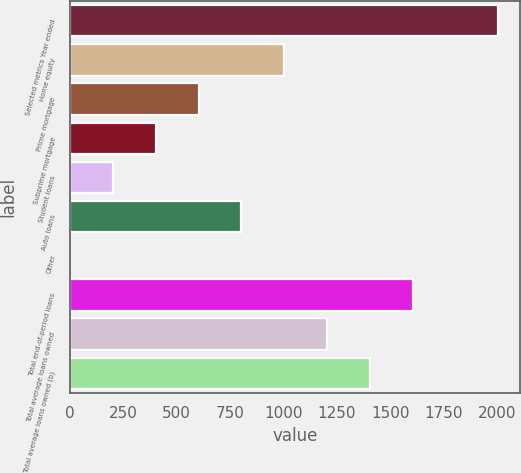Convert chart to OTSL. <chart><loc_0><loc_0><loc_500><loc_500><bar_chart><fcel>Selected metrics Year ended<fcel>Home equity<fcel>Prime mortgage<fcel>Subprime mortgage<fcel>Student loans<fcel>Auto loans<fcel>Other<fcel>Total end-of-period loans<fcel>Total average loans owned<fcel>Total average loans owned (b)<nl><fcel>2007<fcel>1004.55<fcel>603.57<fcel>403.08<fcel>202.59<fcel>804.06<fcel>2.1<fcel>1606.02<fcel>1205.04<fcel>1405.53<nl></chart> 